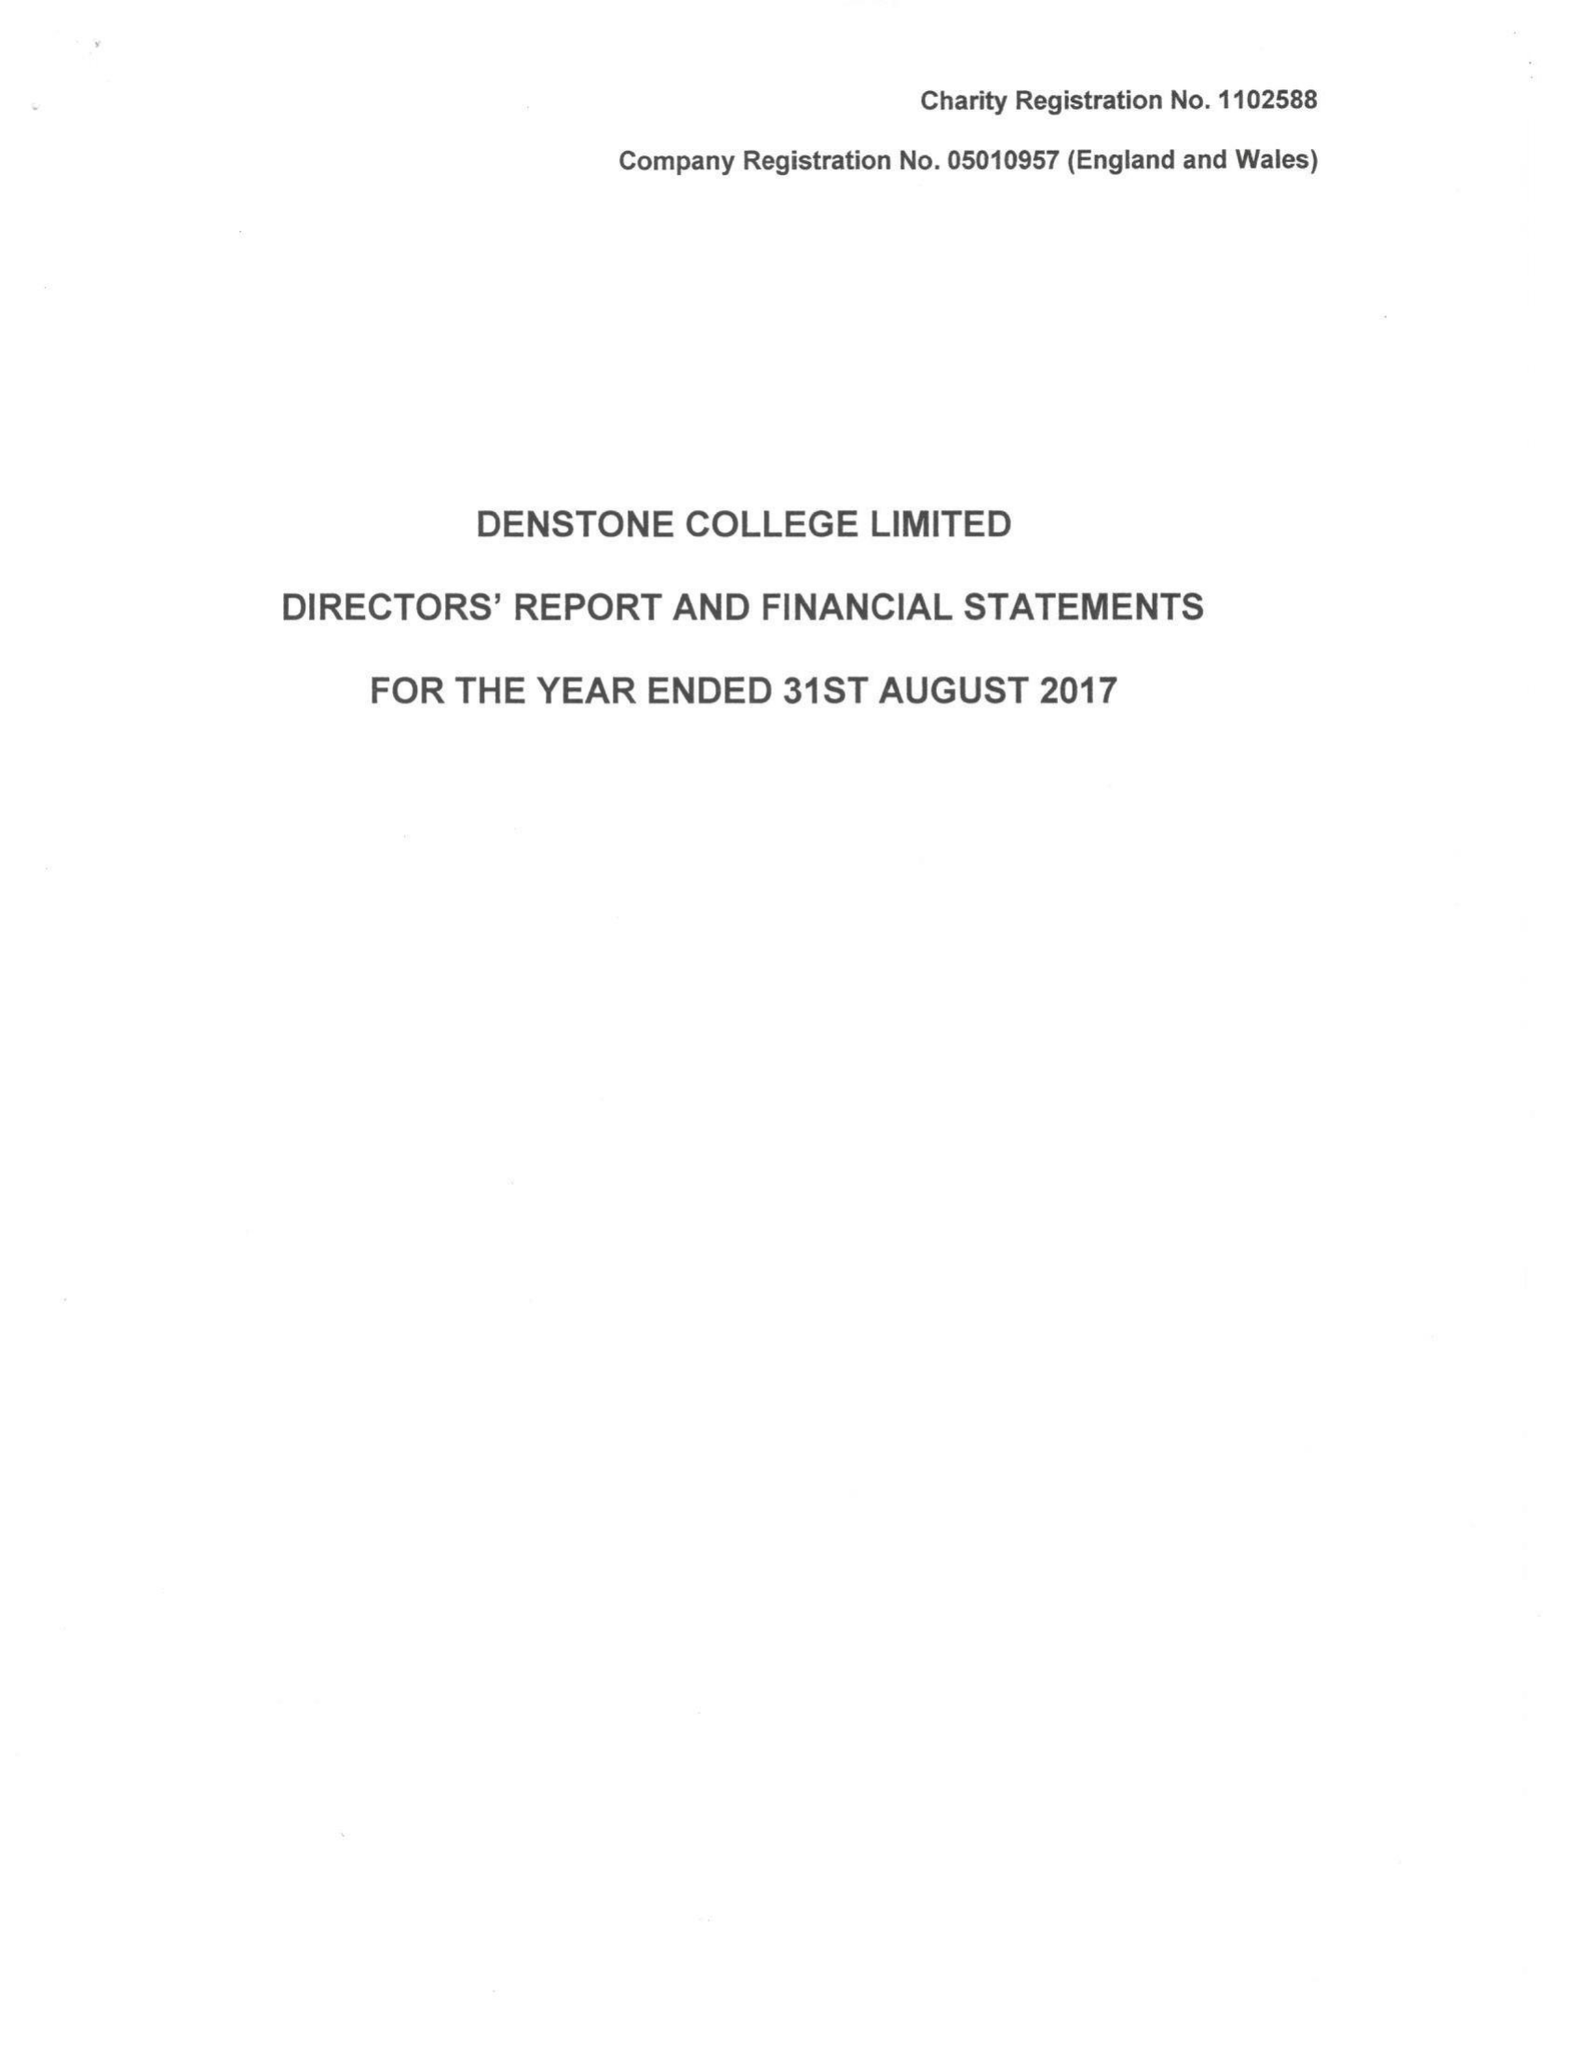What is the value for the address__street_line?
Answer the question using a single word or phrase. None 